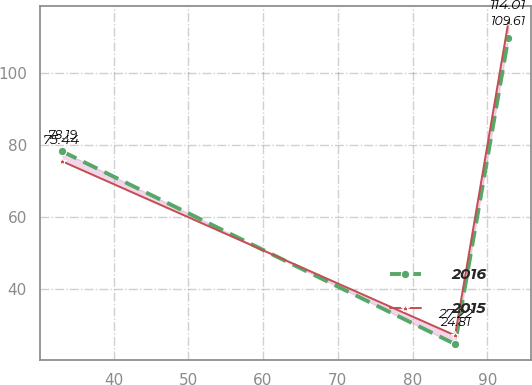Convert chart to OTSL. <chart><loc_0><loc_0><loc_500><loc_500><line_chart><ecel><fcel>2016<fcel>2015<nl><fcel>33.15<fcel>78.19<fcel>75.44<nl><fcel>85.69<fcel>24.81<fcel>27.22<nl><fcel>92.82<fcel>109.61<fcel>114.01<nl></chart> 